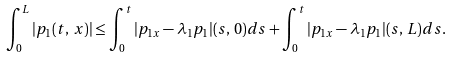Convert formula to latex. <formula><loc_0><loc_0><loc_500><loc_500>\int _ { 0 } ^ { L } | p _ { 1 } ( t , \, x ) | \leq \int _ { 0 } ^ { t } | p _ { 1 x } - \lambda _ { 1 } p _ { 1 } | ( s , \, 0 ) d s + \int _ { 0 } ^ { t } | p _ { 1 x } - \lambda _ { 1 } p _ { 1 } | ( s , \, L ) d s .</formula> 